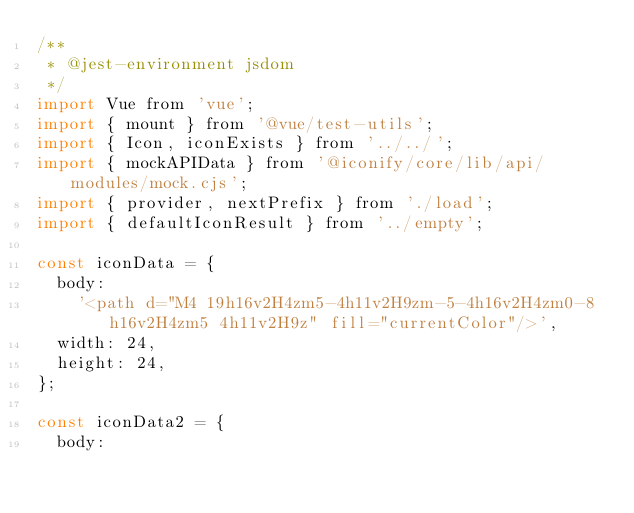<code> <loc_0><loc_0><loc_500><loc_500><_JavaScript_>/**
 * @jest-environment jsdom
 */
import Vue from 'vue';
import { mount } from '@vue/test-utils';
import { Icon, iconExists } from '../../';
import { mockAPIData } from '@iconify/core/lib/api/modules/mock.cjs';
import { provider, nextPrefix } from './load';
import { defaultIconResult } from '../empty';

const iconData = {
	body:
		'<path d="M4 19h16v2H4zm5-4h11v2H9zm-5-4h16v2H4zm0-8h16v2H4zm5 4h11v2H9z" fill="currentColor"/>',
	width: 24,
	height: 24,
};

const iconData2 = {
	body:</code> 